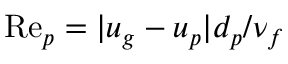Convert formula to latex. <formula><loc_0><loc_0><loc_500><loc_500>R e _ { p } = | u _ { g } - u _ { p } | d _ { p } / \nu _ { f }</formula> 